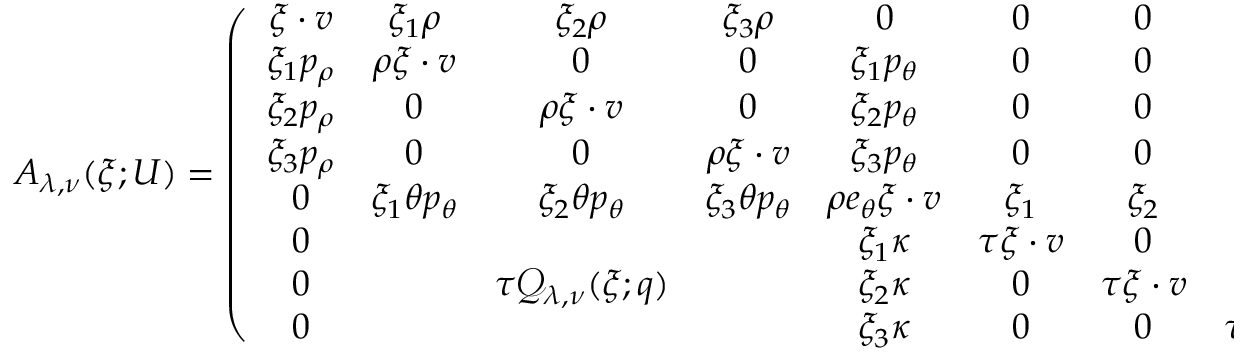<formula> <loc_0><loc_0><loc_500><loc_500>\begin{array} { r } { A _ { \lambda , \nu } ( \xi ; U ) = \left ( \begin{array} { c c c c c c c c } { \xi \cdot v } & { \xi _ { 1 } \rho } & { \xi _ { 2 } \rho } & { \xi _ { 3 } \rho } & { 0 } & { 0 } & { 0 } & { 0 } \\ { \xi _ { 1 } p _ { \rho } } & { \rho \xi \cdot v } & { 0 } & { 0 } & { \xi _ { 1 } p _ { \theta } } & { 0 } & { 0 } & { 0 } \\ { \xi _ { 2 } p _ { \rho } } & { 0 } & { \rho \xi \cdot v } & { 0 } & { \xi _ { 2 } p _ { \theta } } & { 0 } & { 0 } & { 0 } \\ { \xi _ { 3 } p _ { \rho } } & { 0 } & { 0 } & { \rho \xi \cdot v } & { \xi _ { 3 } p _ { \theta } } & { 0 } & { 0 } & { 0 } \\ { 0 } & { \xi _ { 1 } \theta p _ { \theta } } & { \xi _ { 2 } \theta p _ { \theta } } & { \xi _ { 3 } \theta p _ { \theta } } & { \rho e _ { \theta } \xi \cdot v } & { \xi _ { 1 } } & { \xi _ { 2 } } & { \xi _ { 3 } } \\ { 0 } & { \xi _ { 1 } \kappa } & { \tau \xi \cdot v } & { 0 } & { 0 } \\ { 0 } & { \tau \mathcal { Q } _ { \lambda , \nu } ( \xi ; q ) } & { \xi _ { 2 } \kappa } & { 0 } & { \tau \xi \cdot v } & { 0 } \\ { 0 } & { \xi _ { 3 } \kappa } & { 0 } & { 0 } & { \tau \xi \cdot v } \end{array} \right ) , } \end{array}</formula> 